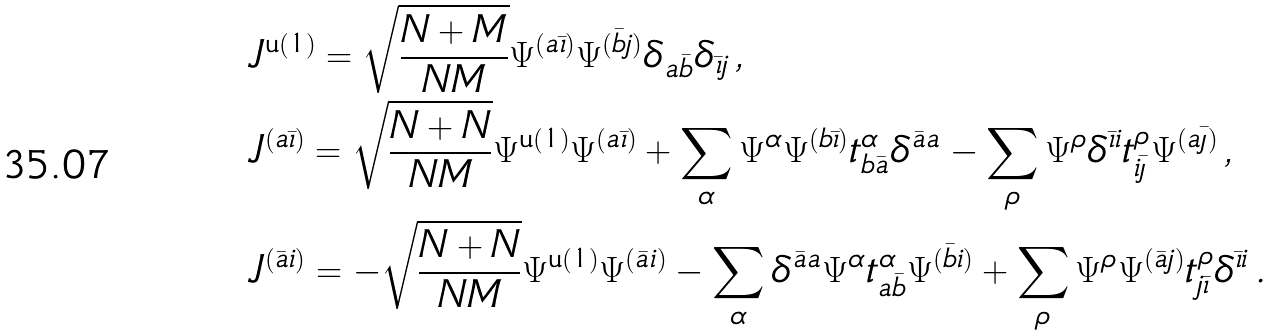Convert formula to latex. <formula><loc_0><loc_0><loc_500><loc_500>& J ^ { \text {u} ( 1 ) } = \sqrt { \frac { N + M } { N M } } \Psi ^ { ( a \bar { \imath } ) } \Psi ^ { ( \bar { b } j ) } \delta _ { a \bar { b } } \delta _ { \bar { \imath } j } \, , \\ & J ^ { ( a \bar { \imath } ) } = \sqrt { \frac { N + N } { N M } } \Psi ^ { \text {u} ( 1 ) } \Psi ^ { ( a \bar { \imath } ) } + \sum _ { \alpha } \Psi ^ { \alpha } \Psi ^ { ( b \bar { \imath } ) } t ^ { \alpha } _ { b \bar { a } } \delta ^ { \bar { a } a } - \sum _ { \rho } \Psi ^ { \rho } \delta ^ { \bar { \imath } i } t ^ { \rho } _ { i \bar { \jmath } } \Psi ^ { ( a \bar { \jmath } ) } \, , \\ & J ^ { ( \bar { a } i ) } = - \sqrt { \frac { N + N } { N M } } \Psi ^ { \text {u} ( 1 ) } \Psi ^ { ( \bar { a } i ) } - \sum _ { \alpha } \delta ^ { \bar { a } a } \Psi ^ { \alpha } t ^ { \alpha } _ { a \bar { b } } \Psi ^ { ( \bar { b } i ) } + \sum _ { \rho } \Psi ^ { \rho } \Psi ^ { ( \bar { a } j ) } t ^ { \rho } _ { j \bar { \imath } } \delta ^ { \bar { \imath } i } \, .</formula> 